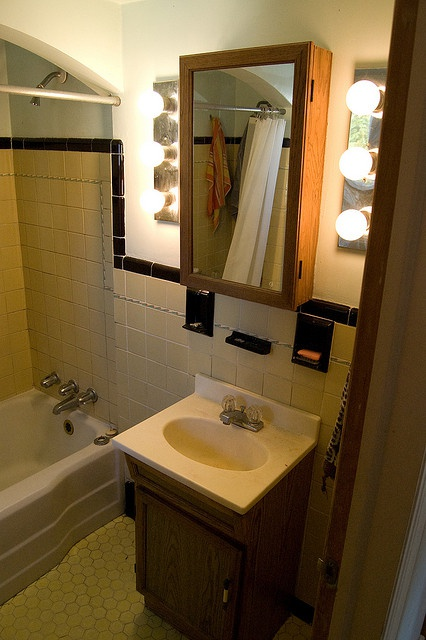Describe the objects in this image and their specific colors. I can see a sink in tan and olive tones in this image. 